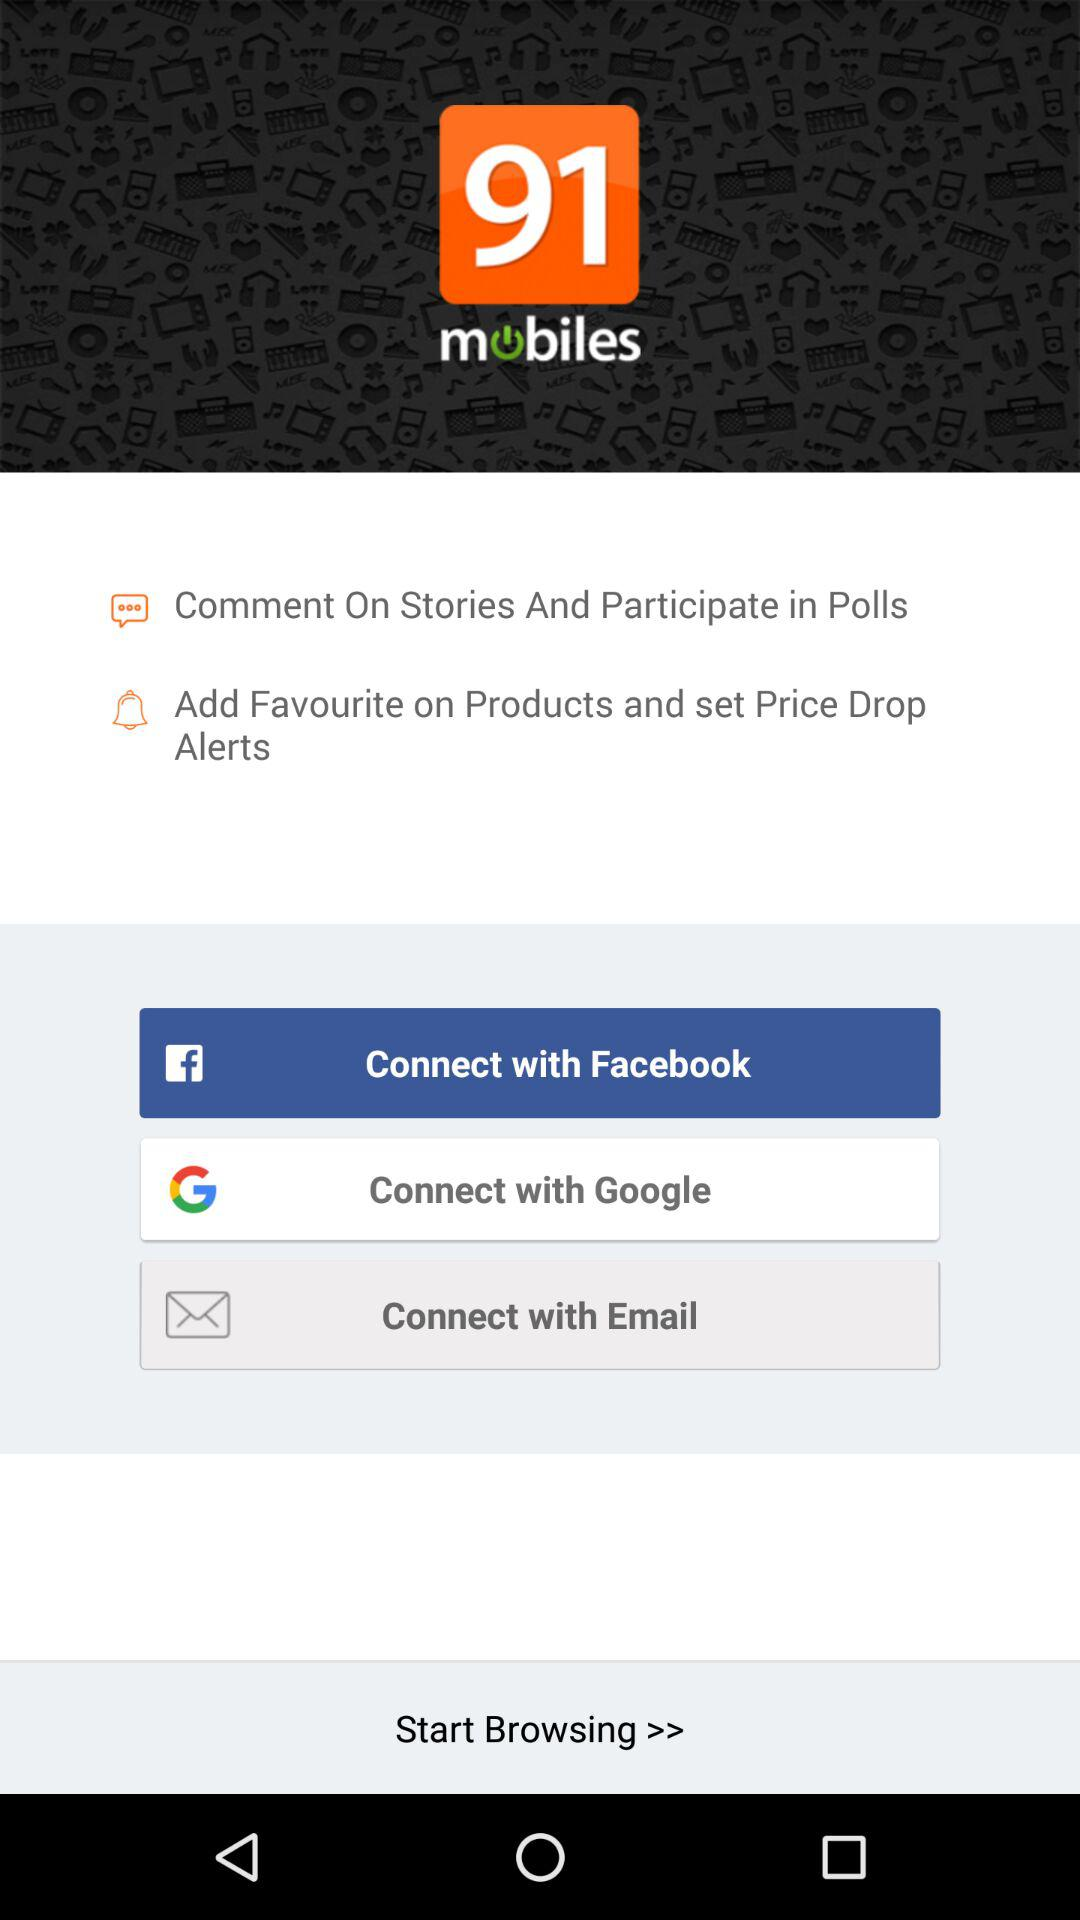What is the application name? The application name is "91mobiles". 